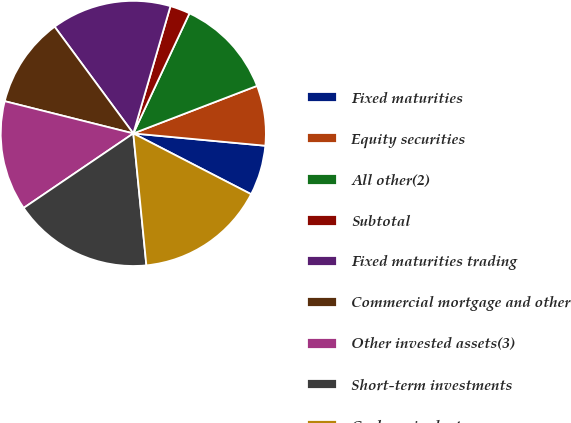Convert chart to OTSL. <chart><loc_0><loc_0><loc_500><loc_500><pie_chart><fcel>Fixed maturities<fcel>Equity securities<fcel>All other(2)<fcel>Subtotal<fcel>Fixed maturities trading<fcel>Commercial mortgage and other<fcel>Other invested assets(3)<fcel>Short-term investments<fcel>Cash equivalents<nl><fcel>6.1%<fcel>7.32%<fcel>12.2%<fcel>2.44%<fcel>14.63%<fcel>10.98%<fcel>13.41%<fcel>17.07%<fcel>15.85%<nl></chart> 